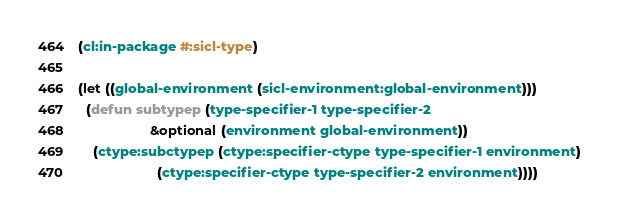Convert code to text. <code><loc_0><loc_0><loc_500><loc_500><_Lisp_>(cl:in-package #:sicl-type)

(let ((global-environment (sicl-environment:global-environment)))
  (defun subtypep (type-specifier-1 type-specifier-2
                   &optional (environment global-environment))
    (ctype:subctypep (ctype:specifier-ctype type-specifier-1 environment)
                     (ctype:specifier-ctype type-specifier-2 environment))))
</code> 